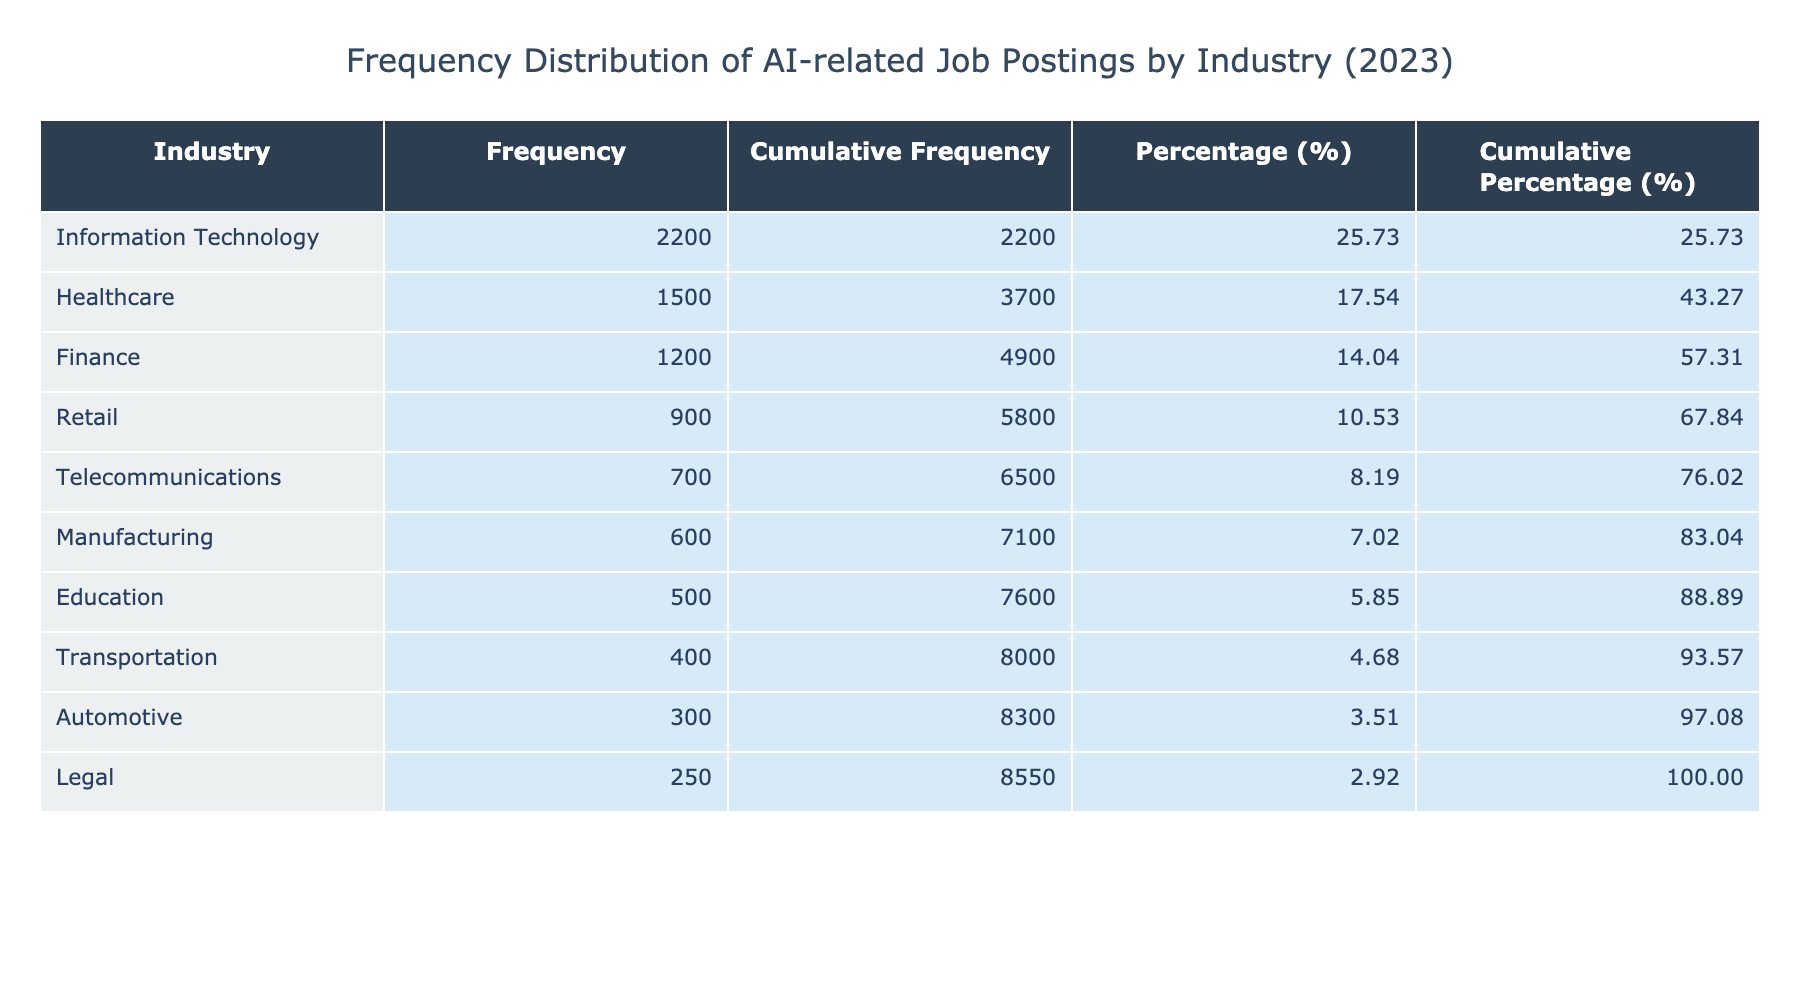What is the frequency of AI job postings in the Information Technology industry? The table lists the frequency of AI job postings by industry. For Information Technology, the entry shows a frequency of 2200.
Answer: 2200 Which industry has the lowest frequency of AI-related job postings? By scanning the frequency figures, I find that the Automotive industry has the lowest frequency at 300.
Answer: Automotive What is the cumulative frequency of AI job postings in the Healthcare industry? The cumulative frequency is calculated by adding all frequencies up to Healthcare: 1500 (Healthcare) + 1200 (Finance) + 2200 (Information Technology) + 900 (Retail) + 600 (Manufacturing) + 400 (Transportation) + 500 (Education) + 700 (Telecommunications) + 300 (Automotive) + 250 (Legal) = 12000. However, since we're only looking up to Healthcare, it's just 1500.
Answer: 1500 Is the frequency of AI job postings in the Finance industry greater than 1000? The Finance industry has 1200 postings, which is indeed greater than 1000. Therefore, the statement is true.
Answer: Yes What percentage of total AI job postings does the Healthcare industry represent? The total frequency of AI job postings is 12000. The percentage for Healthcare is (1500 / 12000) * 100 = 12.5%.
Answer: 12.5 What is the difference in frequency of AI job postings between the Retail and Manufacturing industries? Retail has a frequency of 900, and Manufacturing has 600. The difference is 900 - 600 = 300.
Answer: 300 If we combine the frequencies of Transportation and Automotive industries, what is the total? Transportation has a frequency of 400 and Automotive has 300. Adding these values gives us 400 + 300 = 700.
Answer: 700 Which industry has a frequency of AI job postings that is less than the average frequency? The average frequency can be calculated as total frequencies (12000) divided by number of industries (10), resulting in an average of 1200. The industries with frequency less than 1200 are: Retail (900), Manufacturing (600), Transportation (400), Education (500), Telecommunications (700), and Automotive (300), and Legal (250).
Answer: Retail, Manufacturing, Transportation, Education, Telecommunications, Automotive, Legal Is the total frequency for the top three industries (Information Technology, Healthcare, and Finance) greater than 4000? The top three industries’ frequencies are Information Technology (2200), Healthcare (1500), and Finance (1200). Summing these gives 2200 + 1500 + 1200 = 4900, which is indeed greater than 4000.
Answer: Yes 